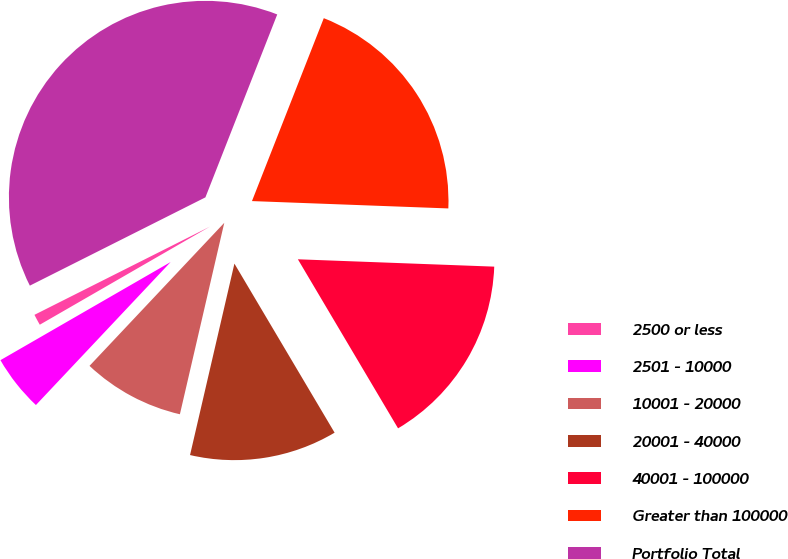Convert chart. <chart><loc_0><loc_0><loc_500><loc_500><pie_chart><fcel>2500 or less<fcel>2501 - 10000<fcel>10001 - 20000<fcel>20001 - 40000<fcel>40001 - 100000<fcel>Greater than 100000<fcel>Portfolio Total<nl><fcel>0.91%<fcel>4.65%<fcel>8.4%<fcel>12.14%<fcel>15.89%<fcel>19.64%<fcel>38.37%<nl></chart> 